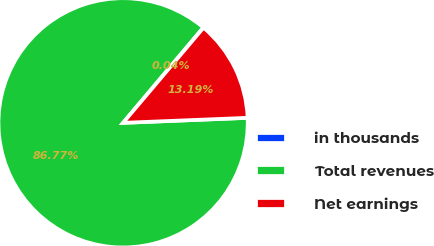Convert chart. <chart><loc_0><loc_0><loc_500><loc_500><pie_chart><fcel>in thousands<fcel>Total revenues<fcel>Net earnings<nl><fcel>0.04%<fcel>86.77%<fcel>13.19%<nl></chart> 